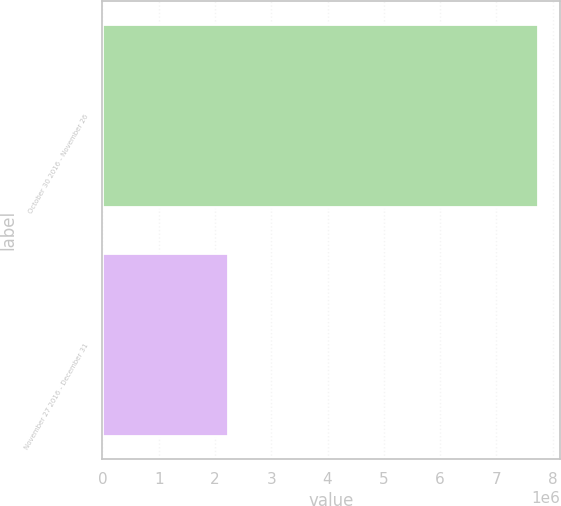Convert chart. <chart><loc_0><loc_0><loc_500><loc_500><bar_chart><fcel>October 30 2016 - November 26<fcel>November 27 2016 - December 31<nl><fcel>7.7424e+06<fcel>2.23824e+06<nl></chart> 